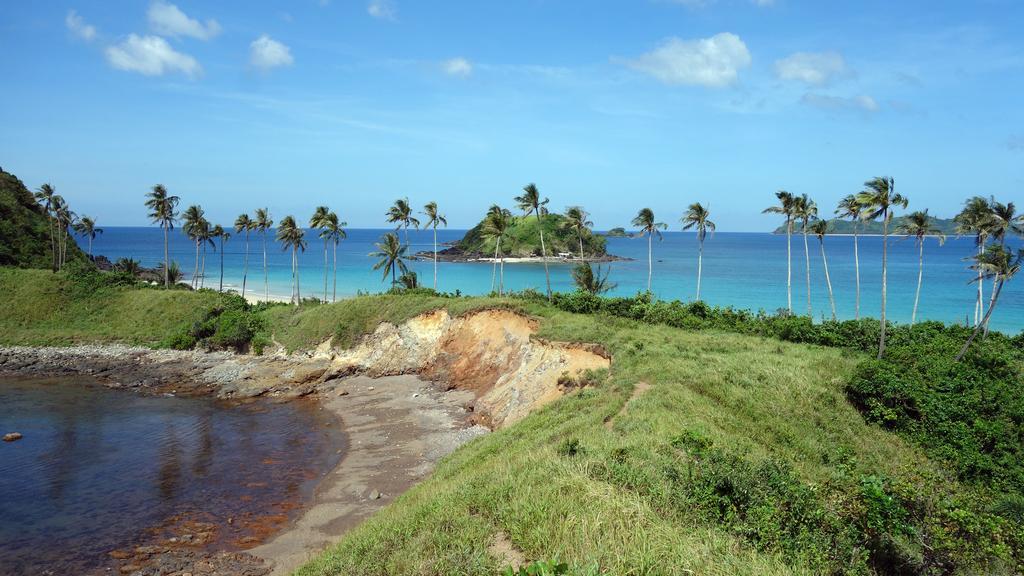Could you give a brief overview of what you see in this image? In this image there are trees on the grassland having plants. Middle of the image there is a hill surrounded by the water. Right side there are hills. Left side there is water. Top of the image there is sky with some clouds. 